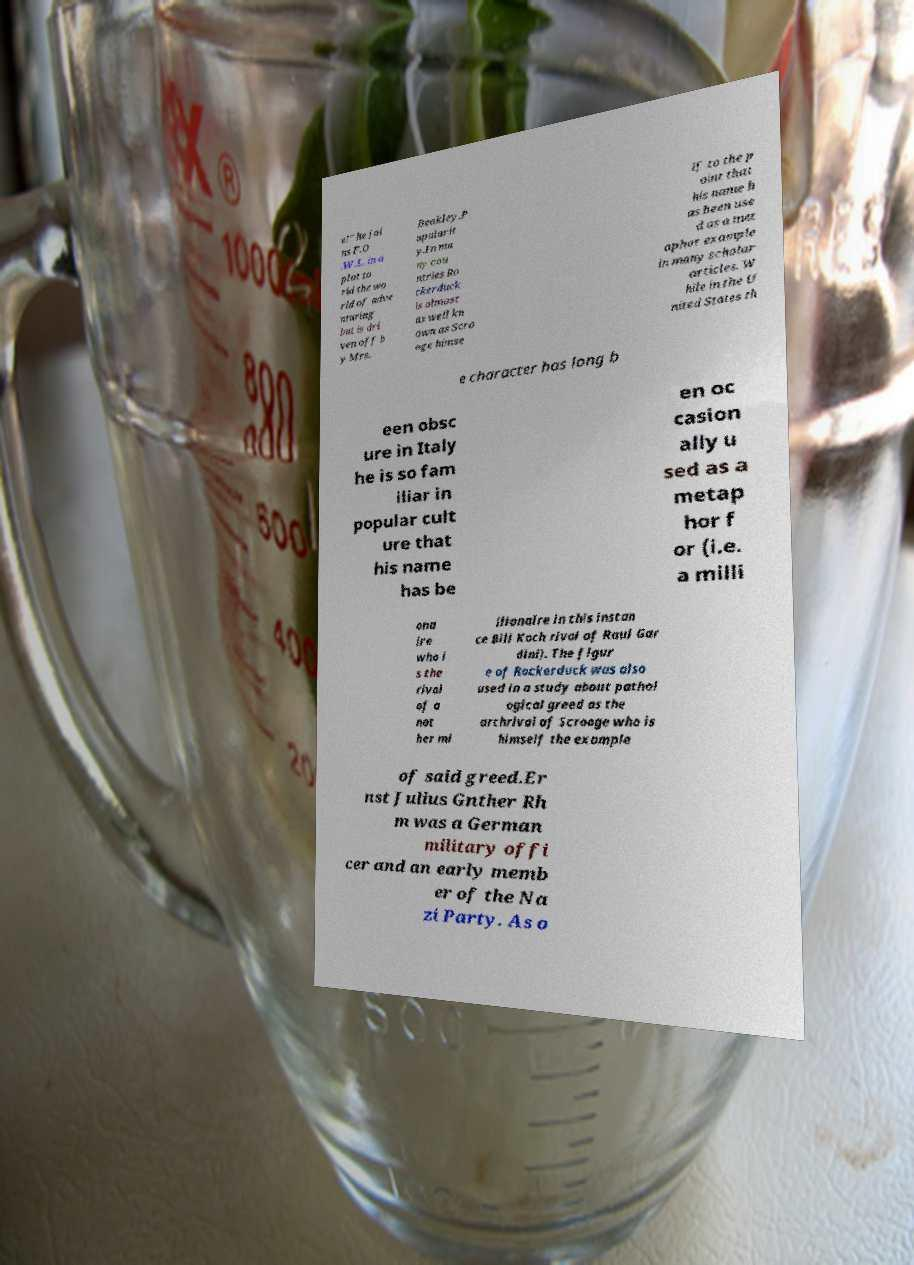Please identify and transcribe the text found in this image. e!" he joi ns F.O .W.L. in a plot to rid the wo rld of adve nturing but is dri ven off b y Mrs. Beakley.P opularit y.In ma ny cou ntries Ro ckerduck is almost as well kn own as Scro oge himse lf to the p oint that his name h as been use d as a met aphor example in many scholar articles. W hile in the U nited States th e character has long b een obsc ure in Italy he is so fam iliar in popular cult ure that his name has be en oc casion ally u sed as a metap hor f or (i.e. a milli ona ire who i s the rival of a not her mi llionaire in this instan ce Bill Koch rival of Raul Gar dini). The figur e of Rockerduck was also used in a study about pathol ogical greed as the archrival of Scrooge who is himself the example of said greed.Er nst Julius Gnther Rh m was a German military offi cer and an early memb er of the Na zi Party. As o 